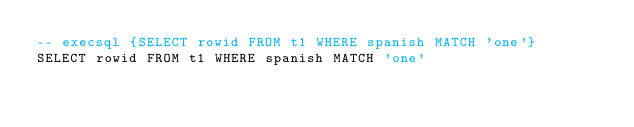Convert code to text. <code><loc_0><loc_0><loc_500><loc_500><_SQL_>-- execsql {SELECT rowid FROM t1 WHERE spanish MATCH 'one'}
SELECT rowid FROM t1 WHERE spanish MATCH 'one'</code> 